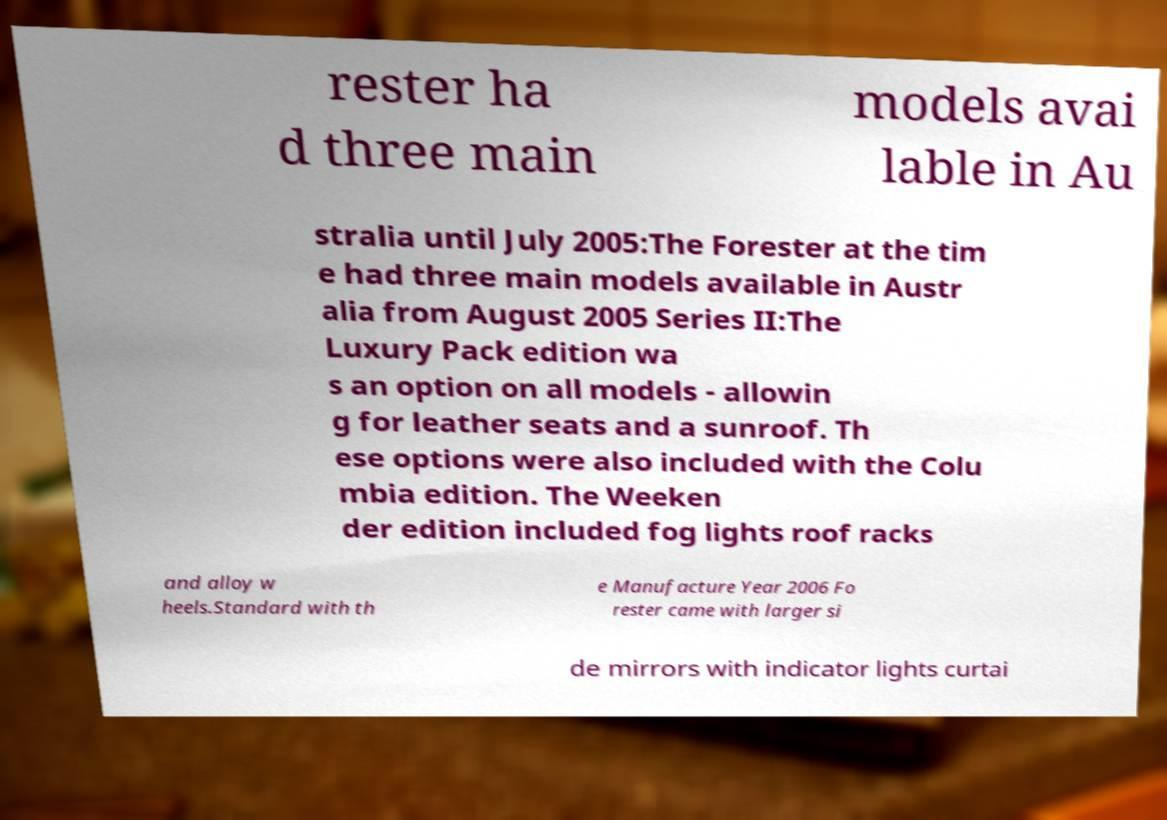Could you assist in decoding the text presented in this image and type it out clearly? rester ha d three main models avai lable in Au stralia until July 2005:The Forester at the tim e had three main models available in Austr alia from August 2005 Series II:The Luxury Pack edition wa s an option on all models - allowin g for leather seats and a sunroof. Th ese options were also included with the Colu mbia edition. The Weeken der edition included fog lights roof racks and alloy w heels.Standard with th e Manufacture Year 2006 Fo rester came with larger si de mirrors with indicator lights curtai 